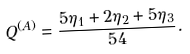Convert formula to latex. <formula><loc_0><loc_0><loc_500><loc_500>Q ^ { ( A ) } & = \frac { 5 \eta _ { 1 } + 2 \eta _ { 2 } + 5 \eta _ { 3 } } { 5 4 } .</formula> 